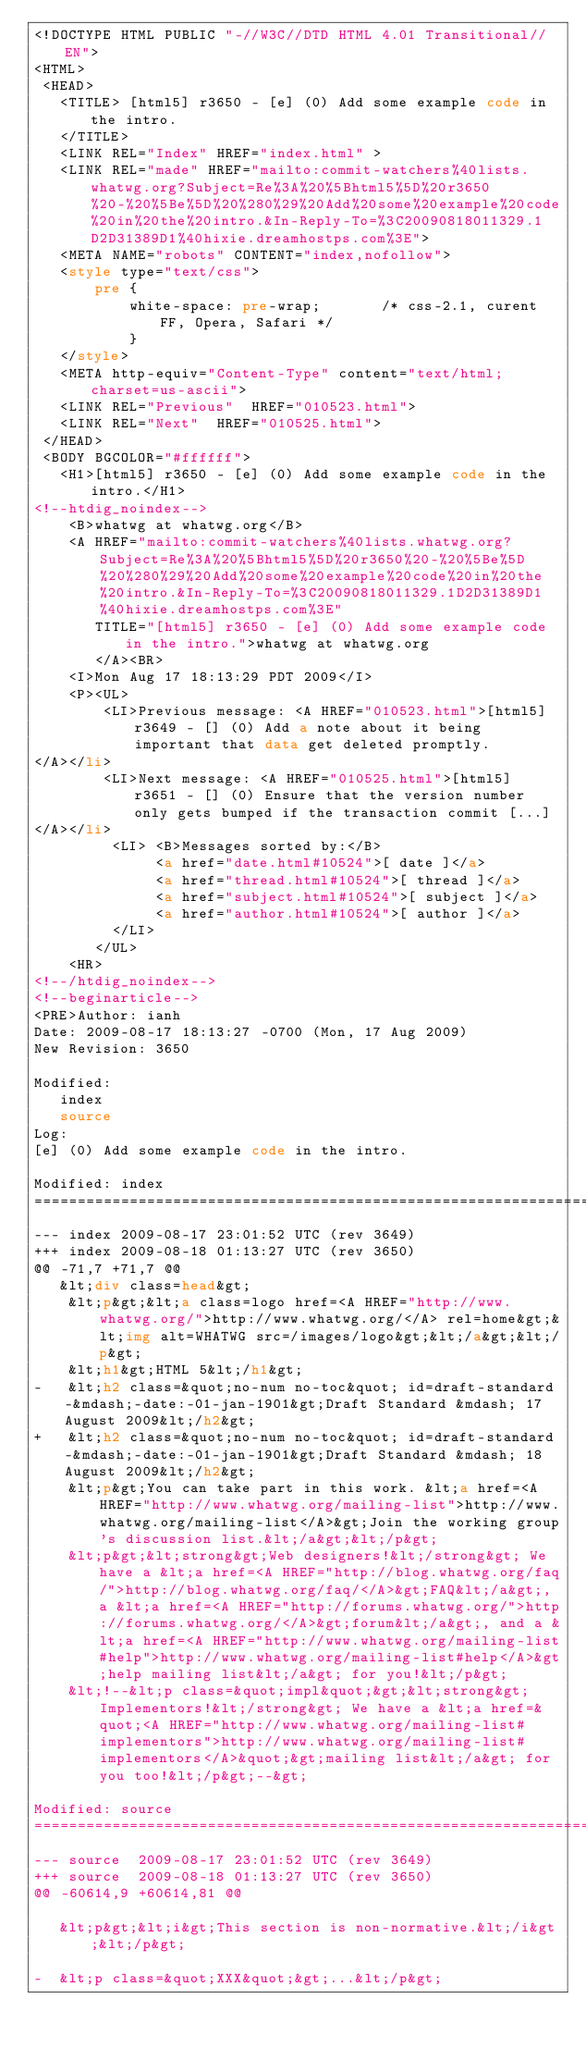Convert code to text. <code><loc_0><loc_0><loc_500><loc_500><_HTML_><!DOCTYPE HTML PUBLIC "-//W3C//DTD HTML 4.01 Transitional//EN">
<HTML>
 <HEAD>
   <TITLE> [html5] r3650 - [e] (0) Add some example code in the intro.
   </TITLE>
   <LINK REL="Index" HREF="index.html" >
   <LINK REL="made" HREF="mailto:commit-watchers%40lists.whatwg.org?Subject=Re%3A%20%5Bhtml5%5D%20r3650%20-%20%5Be%5D%20%280%29%20Add%20some%20example%20code%20in%20the%20intro.&In-Reply-To=%3C20090818011329.1D2D31389D1%40hixie.dreamhostps.com%3E">
   <META NAME="robots" CONTENT="index,nofollow">
   <style type="text/css">
       pre {
           white-space: pre-wrap;       /* css-2.1, curent FF, Opera, Safari */
           }
   </style>
   <META http-equiv="Content-Type" content="text/html; charset=us-ascii">
   <LINK REL="Previous"  HREF="010523.html">
   <LINK REL="Next"  HREF="010525.html">
 </HEAD>
 <BODY BGCOLOR="#ffffff">
   <H1>[html5] r3650 - [e] (0) Add some example code in the intro.</H1>
<!--htdig_noindex-->
    <B>whatwg at whatwg.org</B> 
    <A HREF="mailto:commit-watchers%40lists.whatwg.org?Subject=Re%3A%20%5Bhtml5%5D%20r3650%20-%20%5Be%5D%20%280%29%20Add%20some%20example%20code%20in%20the%20intro.&In-Reply-To=%3C20090818011329.1D2D31389D1%40hixie.dreamhostps.com%3E"
       TITLE="[html5] r3650 - [e] (0) Add some example code in the intro.">whatwg at whatwg.org
       </A><BR>
    <I>Mon Aug 17 18:13:29 PDT 2009</I>
    <P><UL>
        <LI>Previous message: <A HREF="010523.html">[html5] r3649 - [] (0) Add a note about it being important that	data get deleted promptly.
</A></li>
        <LI>Next message: <A HREF="010525.html">[html5] r3651 - [] (0) Ensure that the version number only gets	bumped if the transaction commit [...]
</A></li>
         <LI> <B>Messages sorted by:</B> 
              <a href="date.html#10524">[ date ]</a>
              <a href="thread.html#10524">[ thread ]</a>
              <a href="subject.html#10524">[ subject ]</a>
              <a href="author.html#10524">[ author ]</a>
         </LI>
       </UL>
    <HR>  
<!--/htdig_noindex-->
<!--beginarticle-->
<PRE>Author: ianh
Date: 2009-08-17 18:13:27 -0700 (Mon, 17 Aug 2009)
New Revision: 3650

Modified:
   index
   source
Log:
[e] (0) Add some example code in the intro.

Modified: index
===================================================================
--- index	2009-08-17 23:01:52 UTC (rev 3649)
+++ index	2009-08-18 01:13:27 UTC (rev 3650)
@@ -71,7 +71,7 @@
   &lt;div class=head&gt;
    &lt;p&gt;&lt;a class=logo href=<A HREF="http://www.whatwg.org/">http://www.whatwg.org/</A> rel=home&gt;&lt;img alt=WHATWG src=/images/logo&gt;&lt;/a&gt;&lt;/p&gt;
    &lt;h1&gt;HTML 5&lt;/h1&gt;
-   &lt;h2 class=&quot;no-num no-toc&quot; id=draft-standard-&mdash;-date:-01-jan-1901&gt;Draft Standard &mdash; 17 August 2009&lt;/h2&gt;
+   &lt;h2 class=&quot;no-num no-toc&quot; id=draft-standard-&mdash;-date:-01-jan-1901&gt;Draft Standard &mdash; 18 August 2009&lt;/h2&gt;
    &lt;p&gt;You can take part in this work. &lt;a href=<A HREF="http://www.whatwg.org/mailing-list">http://www.whatwg.org/mailing-list</A>&gt;Join the working group's discussion list.&lt;/a&gt;&lt;/p&gt;
    &lt;p&gt;&lt;strong&gt;Web designers!&lt;/strong&gt; We have a &lt;a href=<A HREF="http://blog.whatwg.org/faq/">http://blog.whatwg.org/faq/</A>&gt;FAQ&lt;/a&gt;, a &lt;a href=<A HREF="http://forums.whatwg.org/">http://forums.whatwg.org/</A>&gt;forum&lt;/a&gt;, and a &lt;a href=<A HREF="http://www.whatwg.org/mailing-list#help">http://www.whatwg.org/mailing-list#help</A>&gt;help mailing list&lt;/a&gt; for you!&lt;/p&gt;
    &lt;!--&lt;p class=&quot;impl&quot;&gt;&lt;strong&gt;Implementors!&lt;/strong&gt; We have a &lt;a href=&quot;<A HREF="http://www.whatwg.org/mailing-list#implementors">http://www.whatwg.org/mailing-list#implementors</A>&quot;&gt;mailing list&lt;/a&gt; for you too!&lt;/p&gt;--&gt;

Modified: source
===================================================================
--- source	2009-08-17 23:01:52 UTC (rev 3649)
+++ source	2009-08-18 01:13:27 UTC (rev 3650)
@@ -60614,9 +60614,81 @@
 
   &lt;p&gt;&lt;i&gt;This section is non-normative.&lt;/i&gt;&lt;/p&gt;
 
-  &lt;p class=&quot;XXX&quot;&gt;...&lt;/p&gt;</code> 